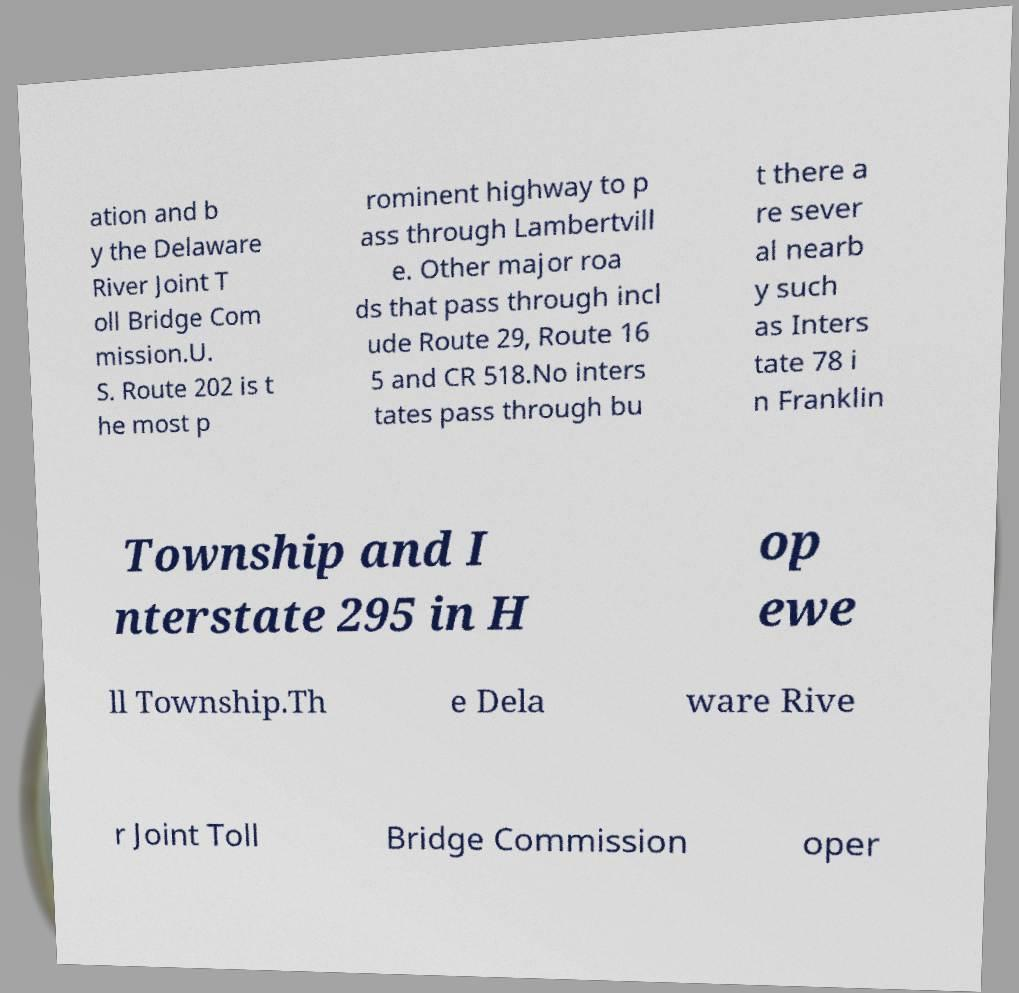Can you accurately transcribe the text from the provided image for me? ation and b y the Delaware River Joint T oll Bridge Com mission.U. S. Route 202 is t he most p rominent highway to p ass through Lambertvill e. Other major roa ds that pass through incl ude Route 29, Route 16 5 and CR 518.No inters tates pass through bu t there a re sever al nearb y such as Inters tate 78 i n Franklin Township and I nterstate 295 in H op ewe ll Township.Th e Dela ware Rive r Joint Toll Bridge Commission oper 